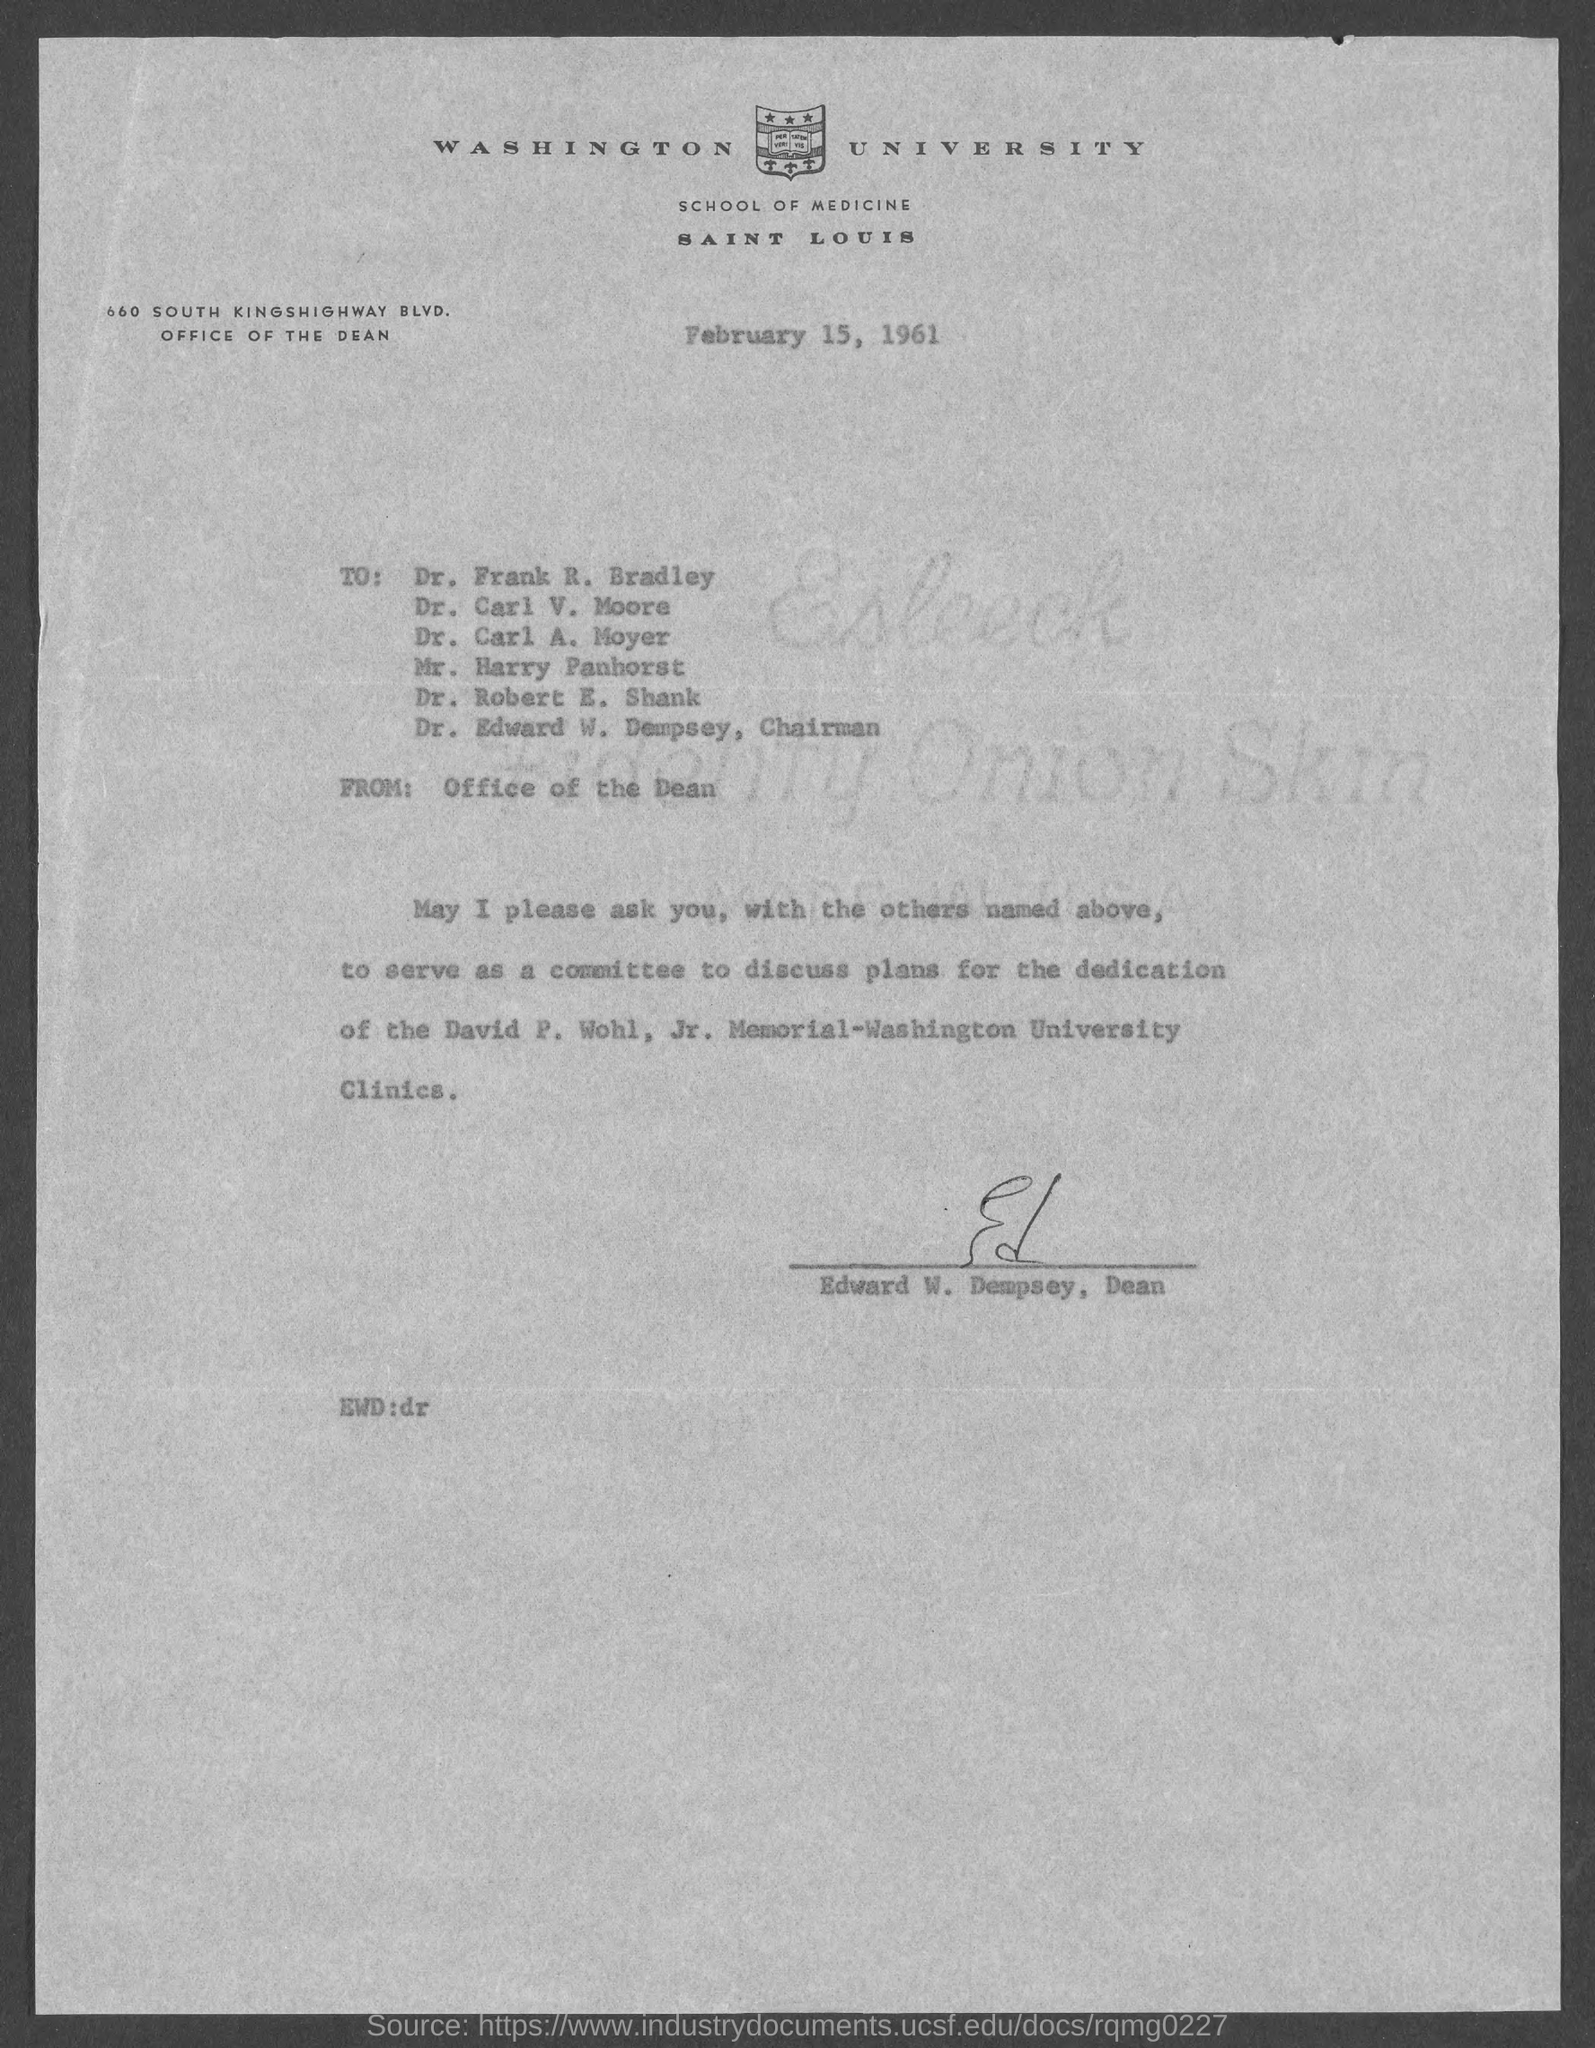Give some essential details in this illustration. Edward W. Dempsey is the Dean of Washington University. The letter is dated February 15, 1961. 